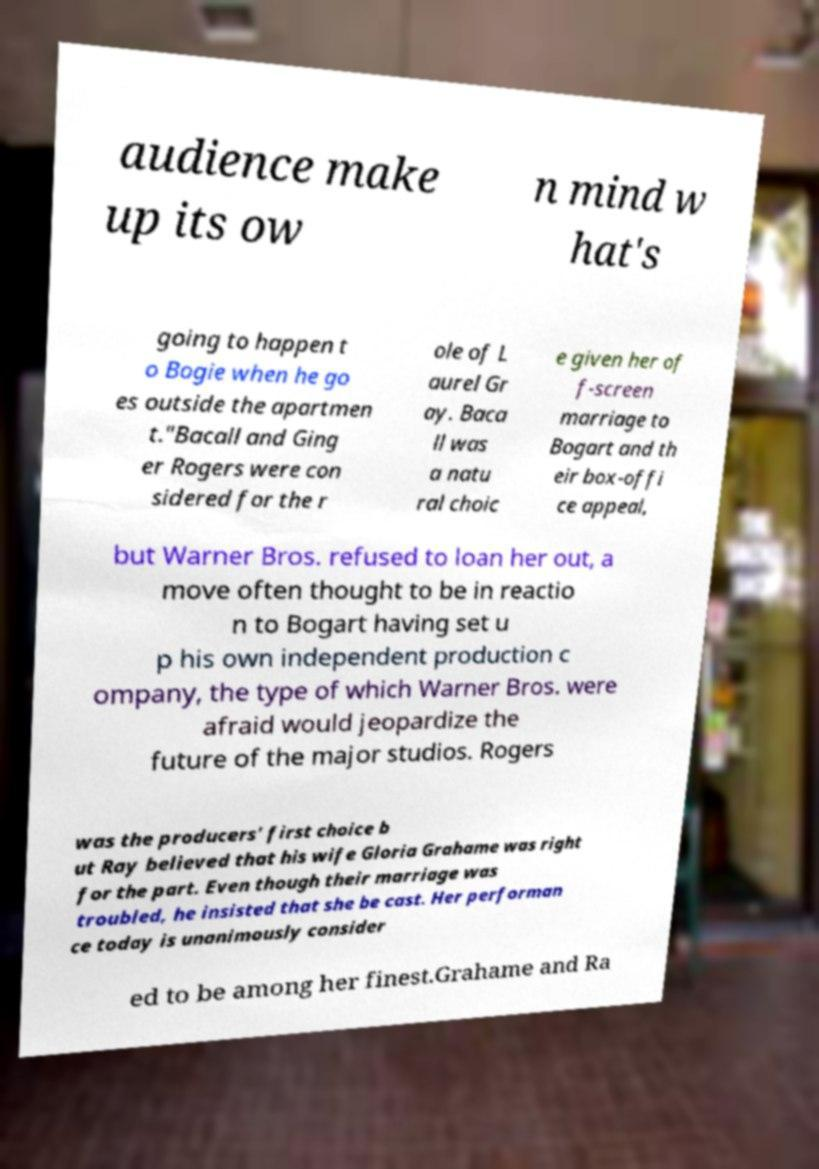Can you accurately transcribe the text from the provided image for me? audience make up its ow n mind w hat's going to happen t o Bogie when he go es outside the apartmen t."Bacall and Ging er Rogers were con sidered for the r ole of L aurel Gr ay. Baca ll was a natu ral choic e given her of f-screen marriage to Bogart and th eir box-offi ce appeal, but Warner Bros. refused to loan her out, a move often thought to be in reactio n to Bogart having set u p his own independent production c ompany, the type of which Warner Bros. were afraid would jeopardize the future of the major studios. Rogers was the producers' first choice b ut Ray believed that his wife Gloria Grahame was right for the part. Even though their marriage was troubled, he insisted that she be cast. Her performan ce today is unanimously consider ed to be among her finest.Grahame and Ra 